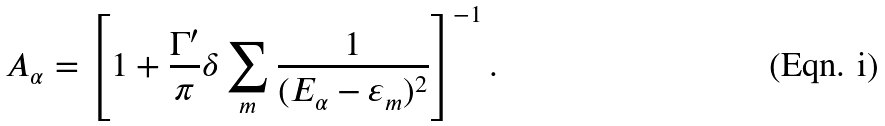Convert formula to latex. <formula><loc_0><loc_0><loc_500><loc_500>A _ { \alpha } = \left [ 1 + \frac { \Gamma ^ { \prime } } { \pi } \delta \sum _ { m } \frac { 1 } { ( E _ { \alpha } - \varepsilon _ { m } ) ^ { 2 } } \right ] ^ { - 1 } .</formula> 